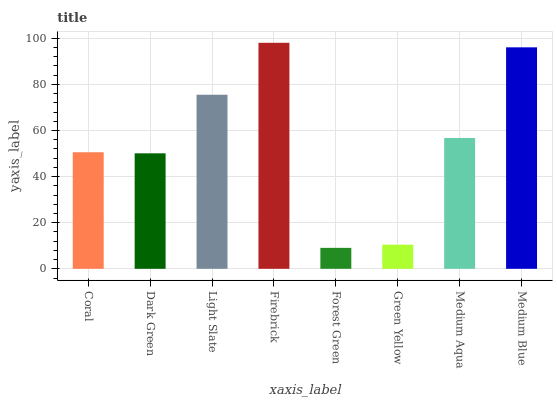Is Dark Green the minimum?
Answer yes or no. No. Is Dark Green the maximum?
Answer yes or no. No. Is Coral greater than Dark Green?
Answer yes or no. Yes. Is Dark Green less than Coral?
Answer yes or no. Yes. Is Dark Green greater than Coral?
Answer yes or no. No. Is Coral less than Dark Green?
Answer yes or no. No. Is Medium Aqua the high median?
Answer yes or no. Yes. Is Coral the low median?
Answer yes or no. Yes. Is Firebrick the high median?
Answer yes or no. No. Is Firebrick the low median?
Answer yes or no. No. 